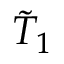Convert formula to latex. <formula><loc_0><loc_0><loc_500><loc_500>\tilde { T } _ { 1 }</formula> 